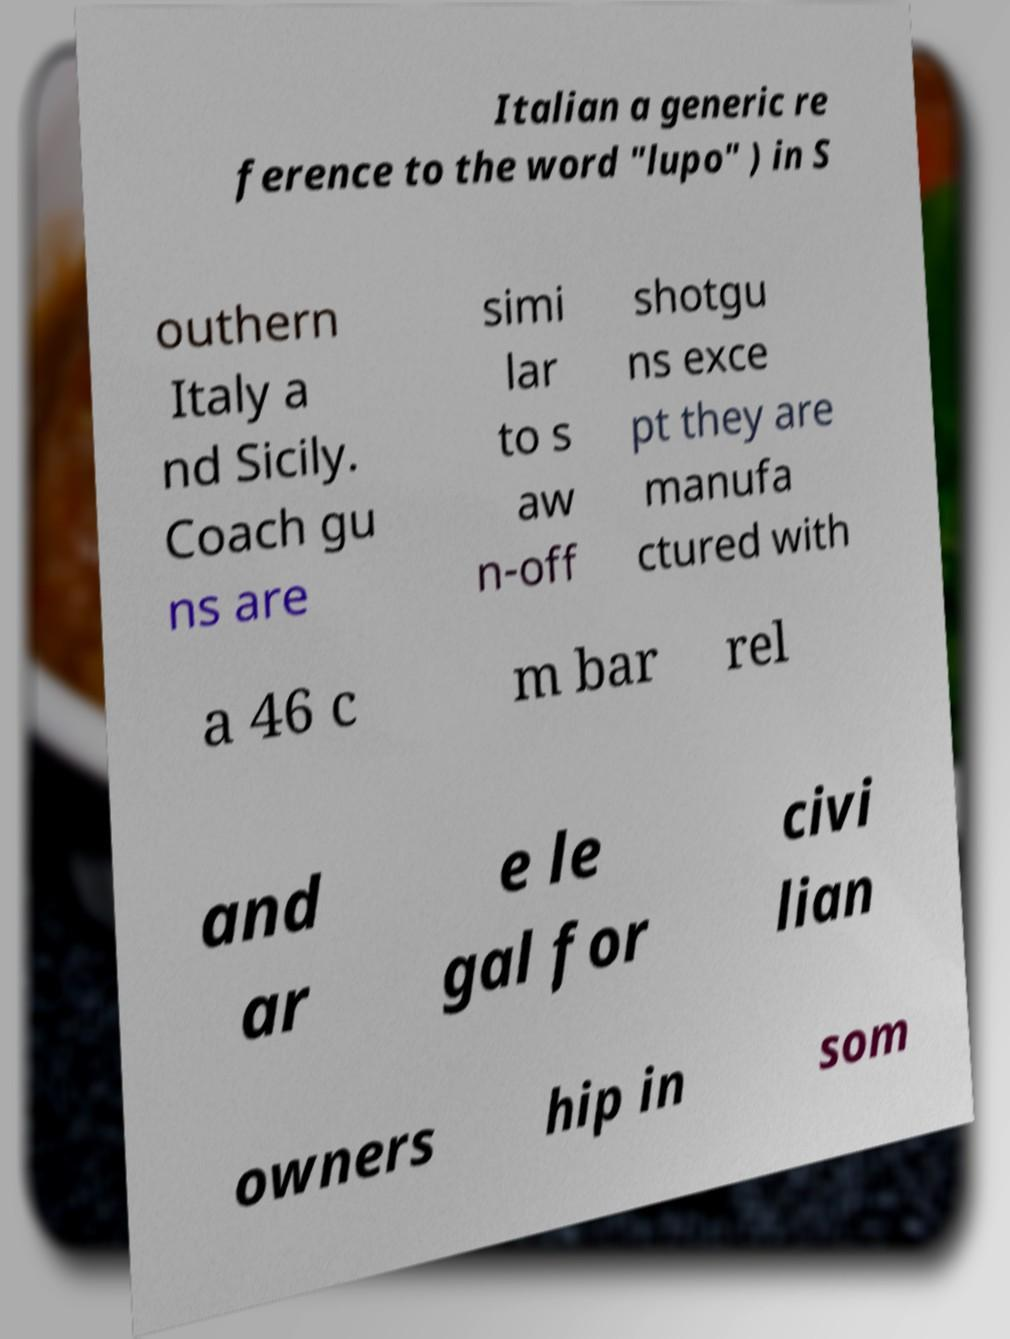Could you assist in decoding the text presented in this image and type it out clearly? Italian a generic re ference to the word "lupo" ) in S outhern Italy a nd Sicily. Coach gu ns are simi lar to s aw n-off shotgu ns exce pt they are manufa ctured with a 46 c m bar rel and ar e le gal for civi lian owners hip in som 